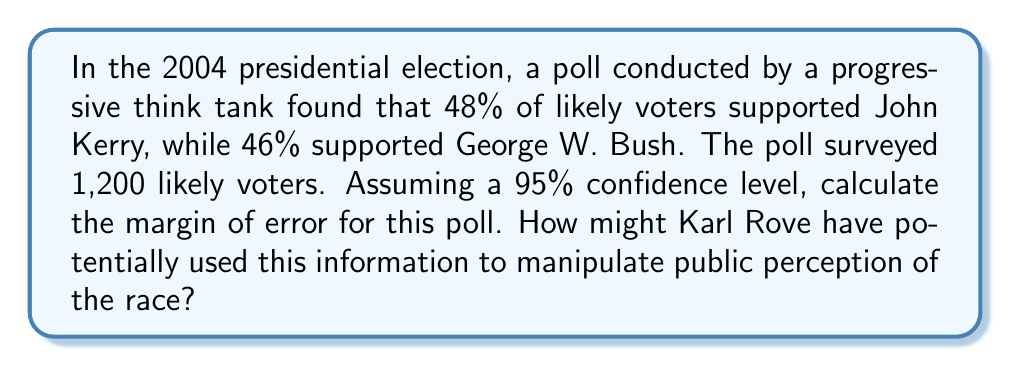Could you help me with this problem? To calculate the margin of error for this poll, we'll use the formula for the margin of error in a proportion:

$$ \text{Margin of Error} = z \sqrt{\frac{p(1-p)}{n}} $$

Where:
- $z$ is the z-score for the desired confidence level
- $p$ is the sample proportion
- $n$ is the sample size

Steps:
1) For a 95% confidence level, $z = 1.96$

2) We'll use the larger proportion (48% for Kerry) as $p$ to get the most conservative estimate:
   $p = 0.48$

3) The sample size $n = 1200$

4) Plugging these values into the formula:

   $$ \text{Margin of Error} = 1.96 \sqrt{\frac{0.48(1-0.48)}{1200}} $$
   
   $$ = 1.96 \sqrt{\frac{0.48 \times 0.52}{1200}} $$
   
   $$ = 1.96 \sqrt{0.000208} $$
   
   $$ = 1.96 \times 0.014422 $$
   
   $$ = 0.02826672 $$

5) Round to three decimal places: 0.028 or 2.8%

Karl Rove might have used this information to manipulate public perception by:
- Emphasizing that the race was "too close to call" within the margin of error, potentially motivating Bush supporters to turn out and vote.
- Downplaying Kerry's lead as statistically insignificant.
- Focusing on other polls that showed Bush ahead, claiming they were just as valid given the margin of error.
Answer: The margin of error for this poll is approximately 2.8%. 